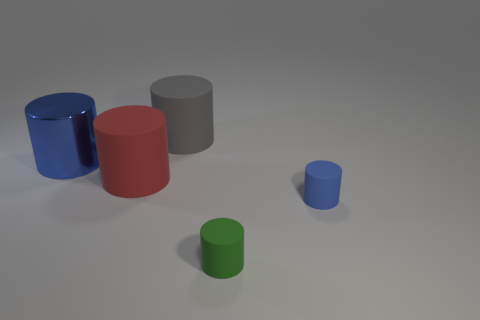Are there any other things that are made of the same material as the big blue thing?
Offer a terse response. No. There is a gray cylinder that is the same size as the red object; what is its material?
Give a very brief answer. Rubber. Is there a tiny gray sphere made of the same material as the gray cylinder?
Offer a terse response. No. Do the blue rubber thing and the large thing behind the blue metal cylinder have the same shape?
Provide a short and direct response. Yes. How many blue objects are to the right of the large metallic object and on the left side of the green cylinder?
Ensure brevity in your answer.  0. Are the green cylinder and the blue object right of the big gray rubber cylinder made of the same material?
Your answer should be very brief. Yes. Are there an equal number of blue metal cylinders that are in front of the large blue cylinder and large purple shiny things?
Provide a short and direct response. Yes. There is a big rubber thing that is in front of the gray cylinder; what color is it?
Give a very brief answer. Red. What number of other things are there of the same color as the big shiny cylinder?
Your response must be concise. 1. Are there any other things that have the same size as the blue metal cylinder?
Your answer should be compact. Yes. 